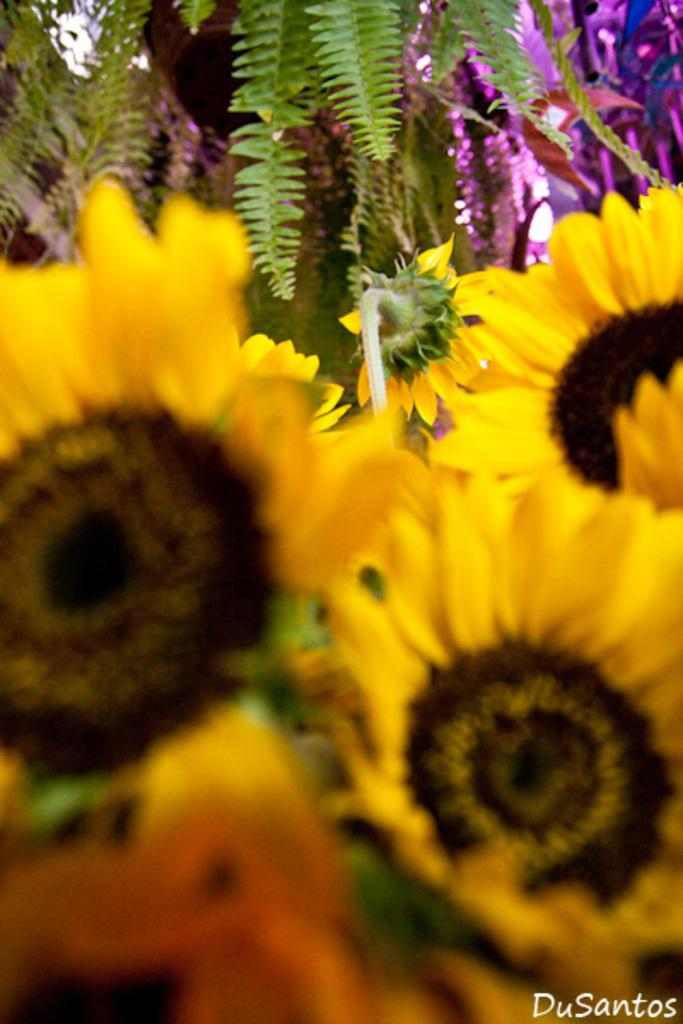What type of plants can be seen in the image? There are flowers in the image. Where are the flowers located in the image? The flowers are in the front of the image. What other type of plant can be seen in the image? There are trees in the image. How are the flowers and trees arranged in the image? The trees are behind the flowers in the image. What type of crack can be seen in the image? There is no crack present in the image. What kind of error is visible in the image? There is no error visible in the image. 